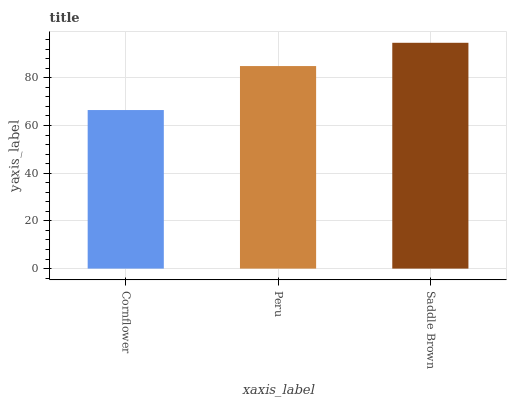Is Cornflower the minimum?
Answer yes or no. Yes. Is Saddle Brown the maximum?
Answer yes or no. Yes. Is Peru the minimum?
Answer yes or no. No. Is Peru the maximum?
Answer yes or no. No. Is Peru greater than Cornflower?
Answer yes or no. Yes. Is Cornflower less than Peru?
Answer yes or no. Yes. Is Cornflower greater than Peru?
Answer yes or no. No. Is Peru less than Cornflower?
Answer yes or no. No. Is Peru the high median?
Answer yes or no. Yes. Is Peru the low median?
Answer yes or no. Yes. Is Saddle Brown the high median?
Answer yes or no. No. Is Cornflower the low median?
Answer yes or no. No. 